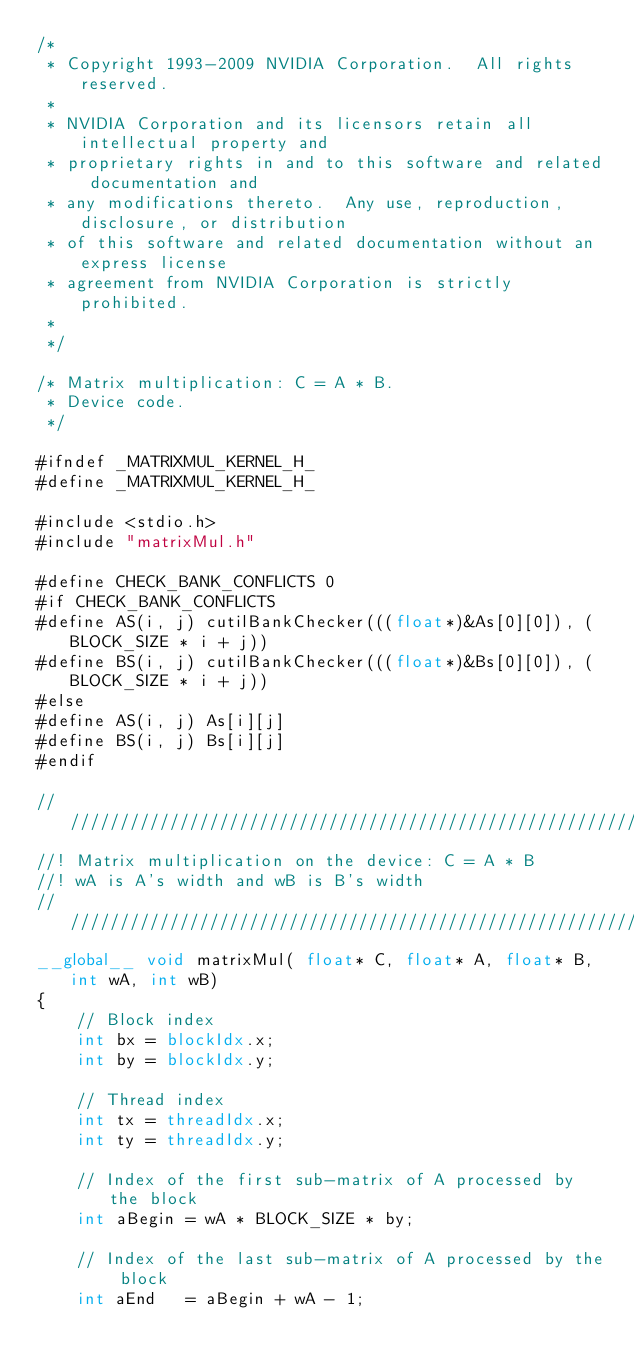<code> <loc_0><loc_0><loc_500><loc_500><_Cuda_>/*
 * Copyright 1993-2009 NVIDIA Corporation.  All rights reserved.
 *
 * NVIDIA Corporation and its licensors retain all intellectual property and 
 * proprietary rights in and to this software and related documentation and 
 * any modifications thereto.  Any use, reproduction, disclosure, or distribution 
 * of this software and related documentation without an express license 
 * agreement from NVIDIA Corporation is strictly prohibited.
 * 
 */

/* Matrix multiplication: C = A * B.
 * Device code.
 */

#ifndef _MATRIXMUL_KERNEL_H_
#define _MATRIXMUL_KERNEL_H_

#include <stdio.h>
#include "matrixMul.h"

#define CHECK_BANK_CONFLICTS 0
#if CHECK_BANK_CONFLICTS
#define AS(i, j) cutilBankChecker(((float*)&As[0][0]), (BLOCK_SIZE * i + j))
#define BS(i, j) cutilBankChecker(((float*)&Bs[0][0]), (BLOCK_SIZE * i + j))
#else
#define AS(i, j) As[i][j]
#define BS(i, j) Bs[i][j]
#endif

////////////////////////////////////////////////////////////////////////////////
//! Matrix multiplication on the device: C = A * B
//! wA is A's width and wB is B's width
////////////////////////////////////////////////////////////////////////////////
__global__ void matrixMul( float* C, float* A, float* B, int wA, int wB)
{
    // Block index
    int bx = blockIdx.x;
    int by = blockIdx.y;

    // Thread index
    int tx = threadIdx.x;
    int ty = threadIdx.y;

    // Index of the first sub-matrix of A processed by the block
    int aBegin = wA * BLOCK_SIZE * by;

    // Index of the last sub-matrix of A processed by the block
    int aEnd   = aBegin + wA - 1;
</code> 